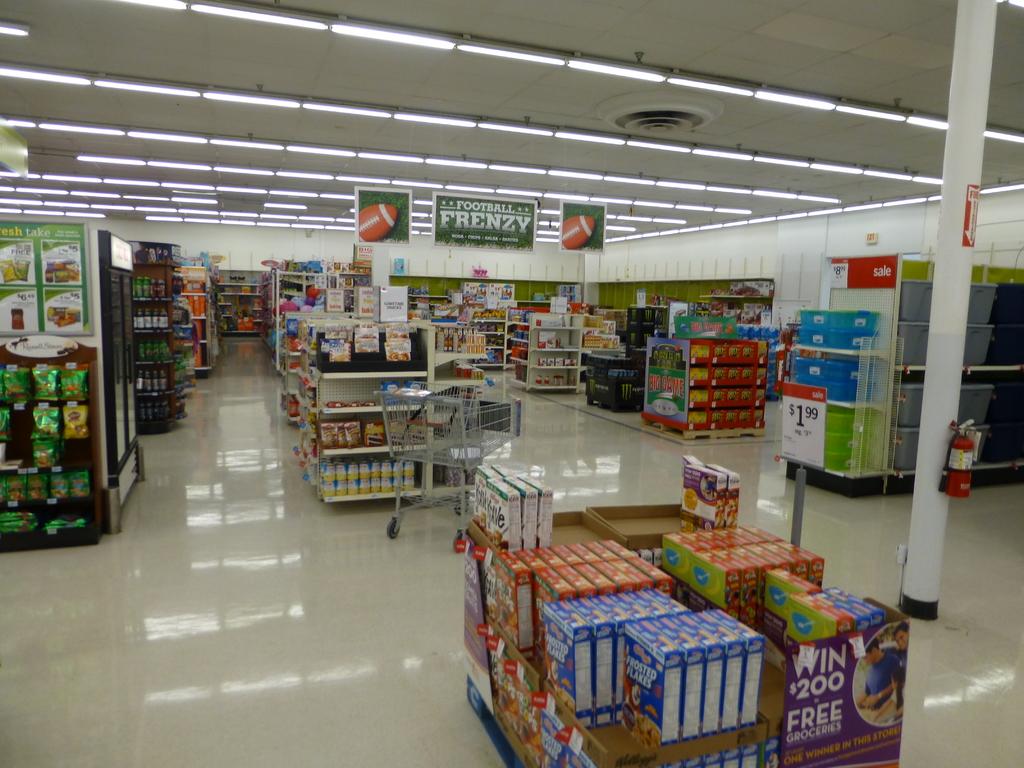What does the purple box say you can win?
Give a very brief answer. $200. What type of sports ball is on the big green sign hanging from the ceiling?
Offer a very short reply. Football. 